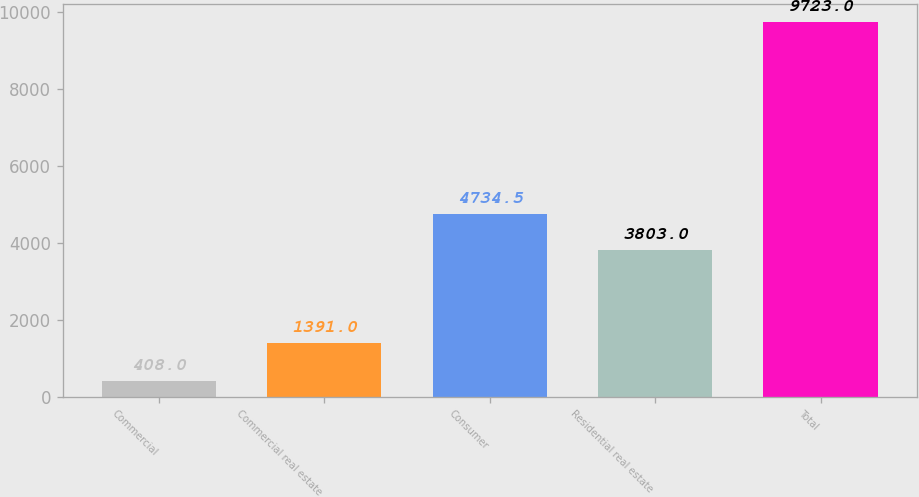Convert chart. <chart><loc_0><loc_0><loc_500><loc_500><bar_chart><fcel>Commercial<fcel>Commercial real estate<fcel>Consumer<fcel>Residential real estate<fcel>Total<nl><fcel>408<fcel>1391<fcel>4734.5<fcel>3803<fcel>9723<nl></chart> 